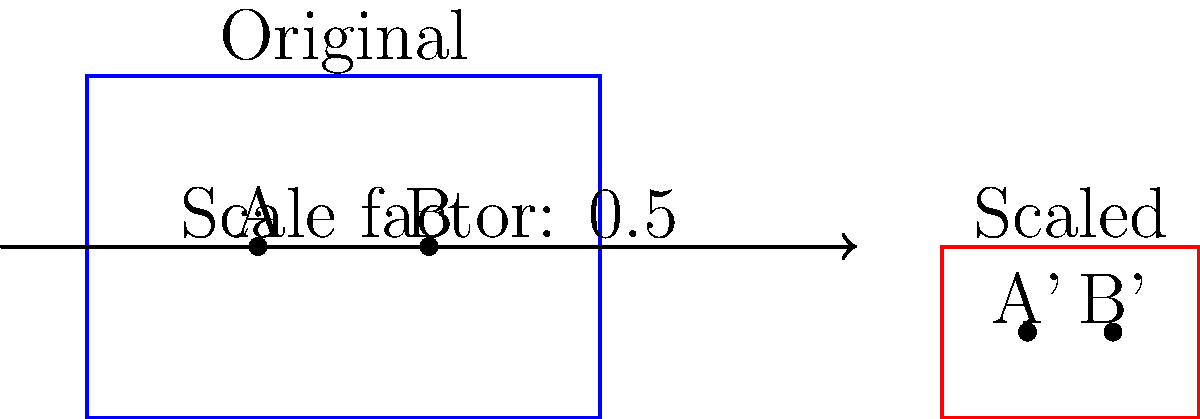In a miniature diorama project, you need to scale down a scene by a factor of 0.5. If the original distance between two elements A and B in the diorama is 10 cm, what will be the new distance between the scaled elements A' and B' to maintain visual consistency? To maintain visual consistency when scaling a diorama, we need to apply the scale factor uniformly to all dimensions. Let's approach this step-by-step:

1. Identify the given information:
   - Original scale: 1:1
   - New scale factor: 0.5 (half the original size)
   - Original distance between A and B: 10 cm

2. Understand the concept of scaling:
   When we scale an object, all its dimensions are multiplied by the scale factor.

3. Apply the scale factor to the distance:
   New distance = Original distance × Scale factor
   New distance = 10 cm × 0.5

4. Calculate the result:
   New distance = 5 cm

Therefore, to maintain visual consistency in the scaled-down diorama, the new distance between elements A' and B' should be 5 cm.
Answer: 5 cm 